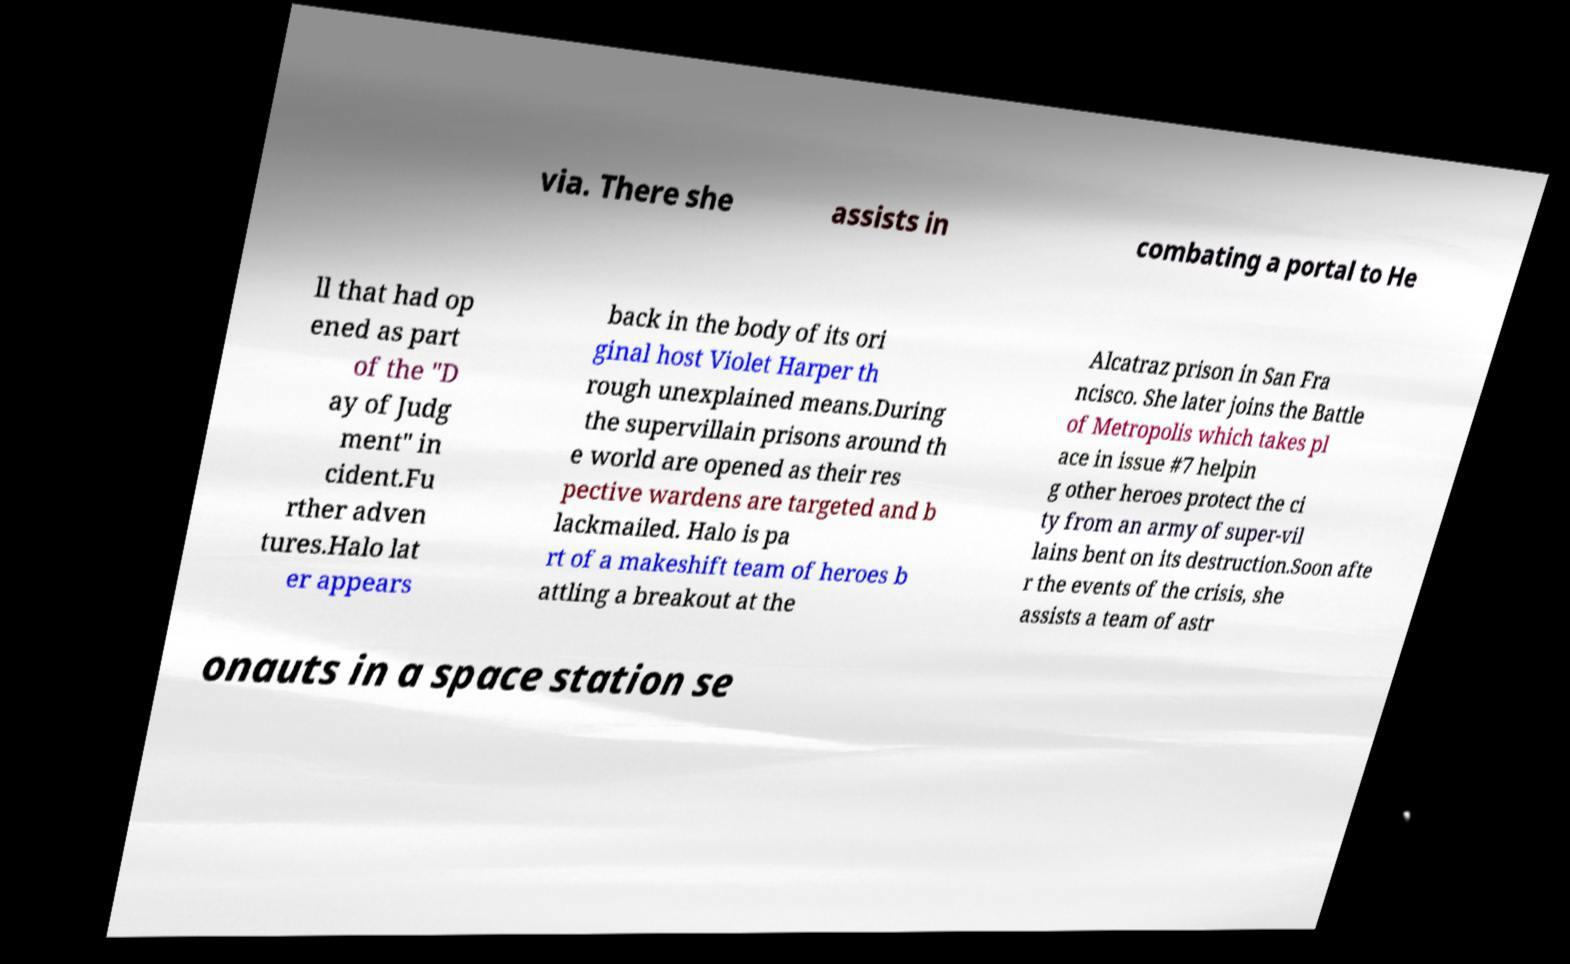Could you extract and type out the text from this image? via. There she assists in combating a portal to He ll that had op ened as part of the "D ay of Judg ment" in cident.Fu rther adven tures.Halo lat er appears back in the body of its ori ginal host Violet Harper th rough unexplained means.During the supervillain prisons around th e world are opened as their res pective wardens are targeted and b lackmailed. Halo is pa rt of a makeshift team of heroes b attling a breakout at the Alcatraz prison in San Fra ncisco. She later joins the Battle of Metropolis which takes pl ace in issue #7 helpin g other heroes protect the ci ty from an army of super-vil lains bent on its destruction.Soon afte r the events of the crisis, she assists a team of astr onauts in a space station se 